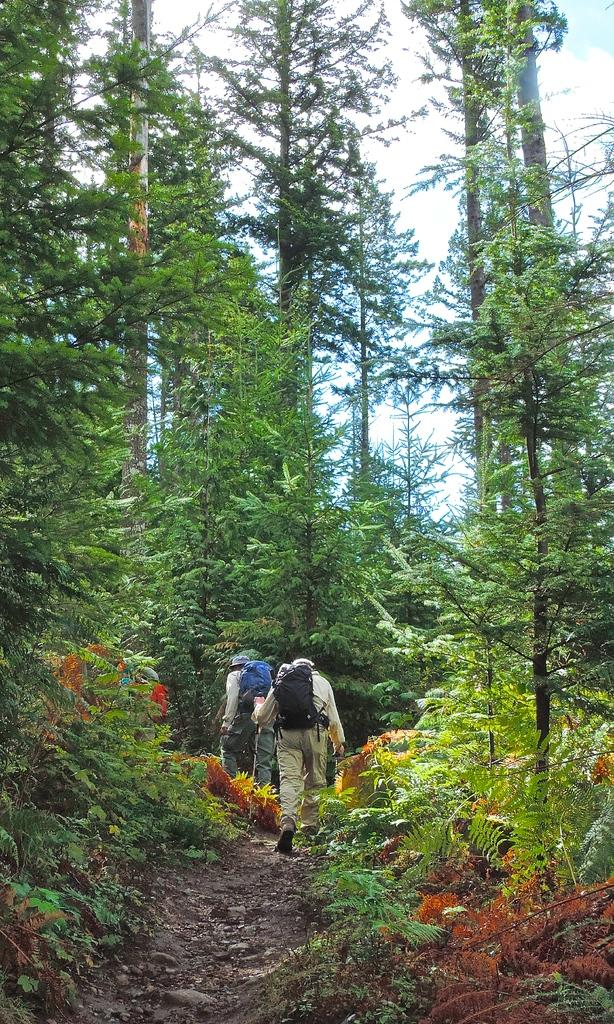What type of vegetation can be seen in the image? There are trees and a plant in the image. What are the people in the image doing? The people are walking on the ground and carrying bags in the image. What can be seen in the background of the image? The sky is visible in the background of the image. How does the visitor feel about the approval of the plant in the image? There is no visitor present in the image, and there is no indication of approval or disapproval of the plant. 